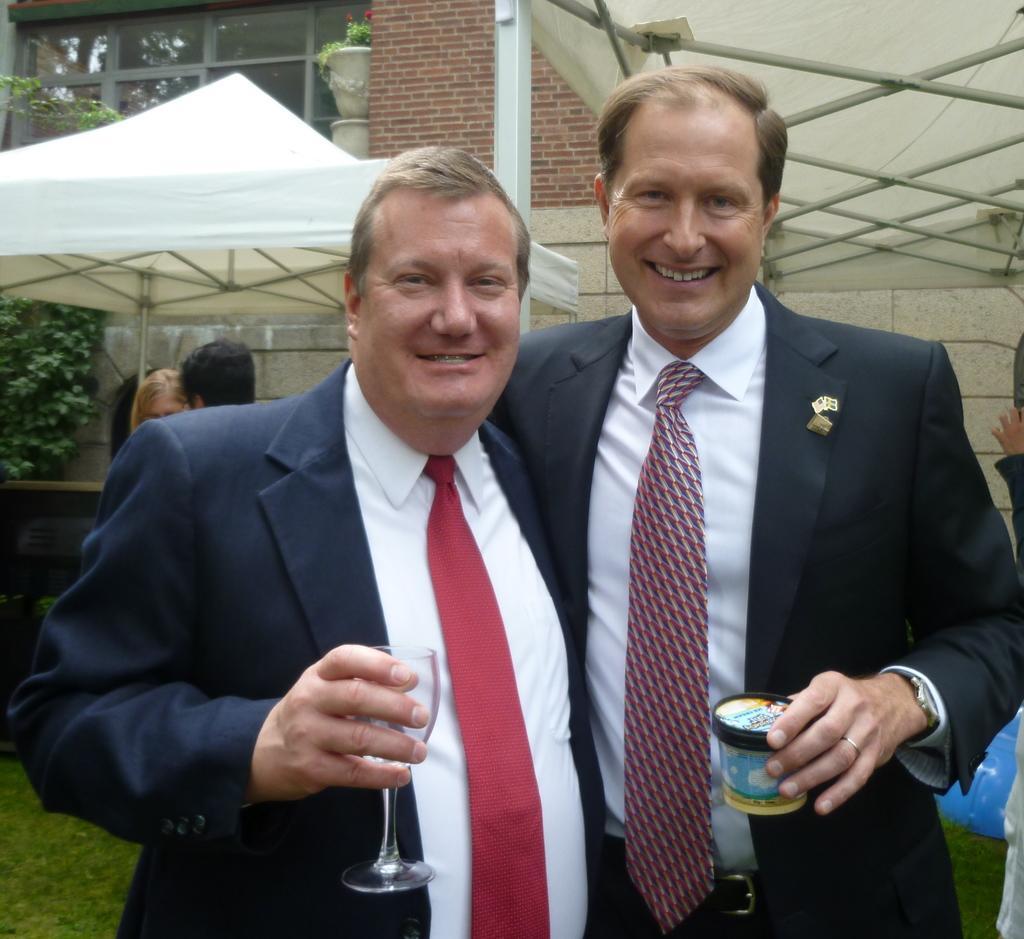Could you give a brief overview of what you see in this image? In this picture there are two men wearing a black coat holding the glass in the hand. smiling and giving a pose into the camera. Behind there is a white canopy shed and brown color brick house. 